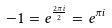Convert formula to latex. <formula><loc_0><loc_0><loc_500><loc_500>- 1 = e ^ { \frac { 2 \pi i } { 2 } } = e ^ { \pi i }</formula> 